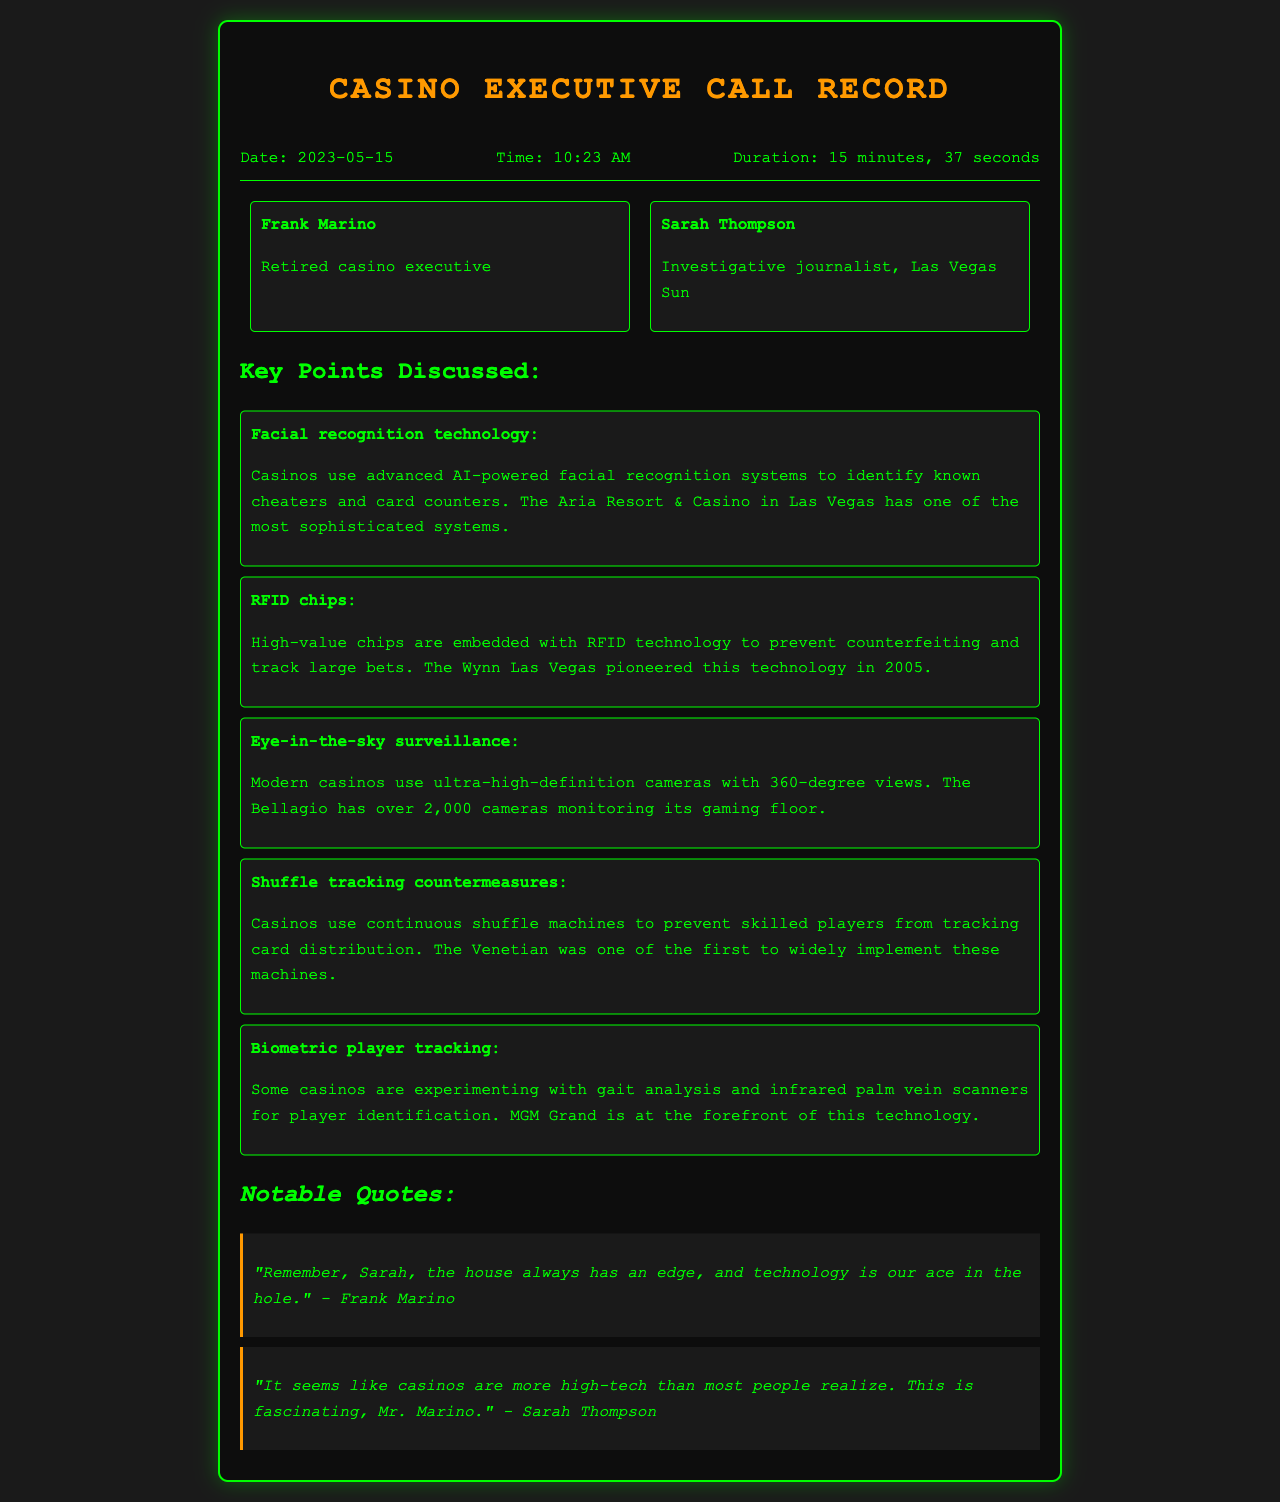what is the name of the journalist? The document mentions Sarah Thompson as the investigative journalist from Las Vegas Sun.
Answer: Sarah Thompson what date did the call occur? The call took place on May 15, 2023, as stated in the call info section.
Answer: 2023-05-15 which casino is known for its sophisticated facial recognition system? The document states that the Aria Resort & Casino in Las Vegas has an advanced facial recognition system.
Answer: Aria Resort & Casino how many cameras does the Bellagio have monitoring its gaming floor? The document specifies that the Bellagio has over 2,000 cameras for surveillance.
Answer: over 2,000 what technology does MGM Grand experiment with for player identification? The document mentions that MGM Grand is experimenting with infrared palm vein scanners for identification.
Answer: infrared palm vein scanners what is the key measure against skilled players tracking card distribution? The Venetian implemented continuous shuffle machines as a countermeasure against card tracking.
Answer: continuous shuffle machines what notable quote did Frank Marino provide about the house edge? Frank Marino stated, "the house always has an edge, and technology is our ace in the hole."
Answer: the house always has an edge, and technology is our ace in the hole what is the duration of the phone call? The duration of the call is specified as 15 minutes and 37 seconds.
Answer: 15 minutes, 37 seconds which casino was the first to pioneer RFID technology for chips? The document attributes the pioneering of RFID technology in casinos to Wynn Las Vegas in 2005.
Answer: Wynn Las Vegas 